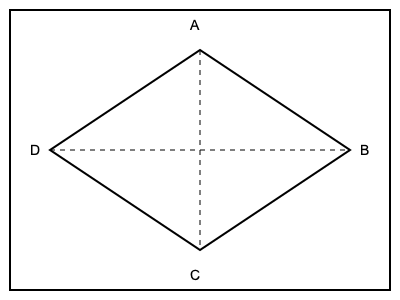When folding an origami crane, one of the steps involves creating a kite-shaped fold. If the resulting shape has four equal sides, what geometric shape is formed when connecting the midpoints of these sides? 1. The kite-shaped fold is represented by the outer shape ABCD in the diagram.
2. The midpoints of the sides are connected by the dashed lines.
3. These dashed lines intersect at right angles, creating four congruent triangles.
4. Each of these triangles is a right-angled triangle.
5. The four triangles together form a square, as all sides are equal (being the midpoints of equal sides of the kite), and all angles are right angles.
6. In origami, this square shape is known as the "base square" or "preliminary base," which is fundamental in many traditional designs.
Answer: Square 